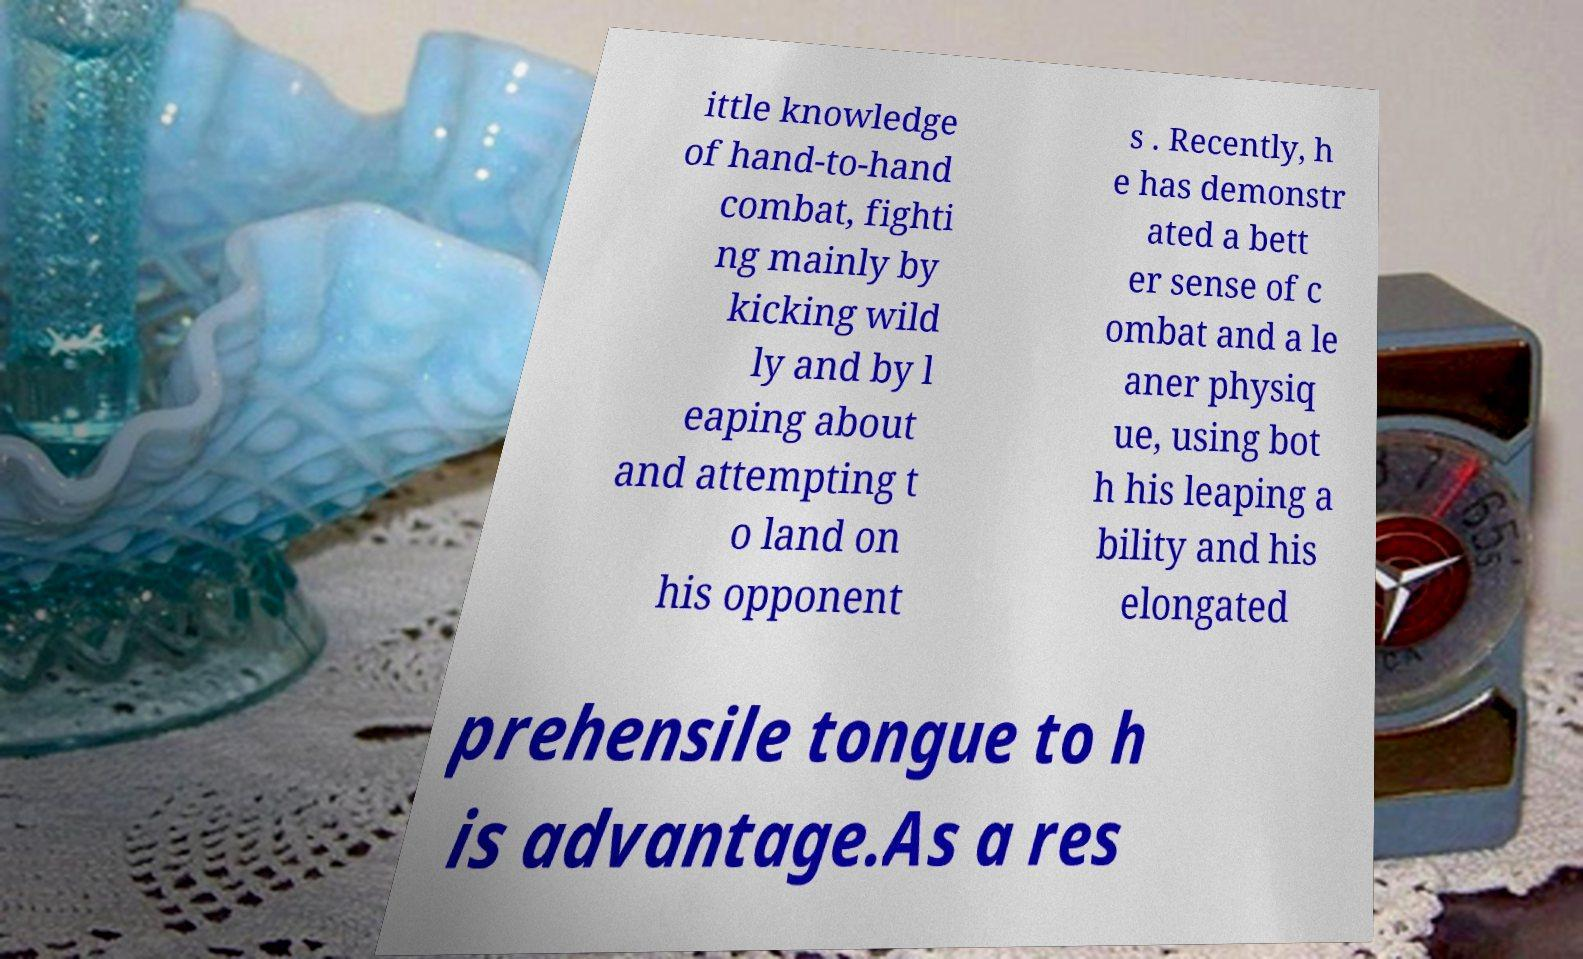Could you extract and type out the text from this image? ittle knowledge of hand-to-hand combat, fighti ng mainly by kicking wild ly and by l eaping about and attempting t o land on his opponent s . Recently, h e has demonstr ated a bett er sense of c ombat and a le aner physiq ue, using bot h his leaping a bility and his elongated prehensile tongue to h is advantage.As a res 